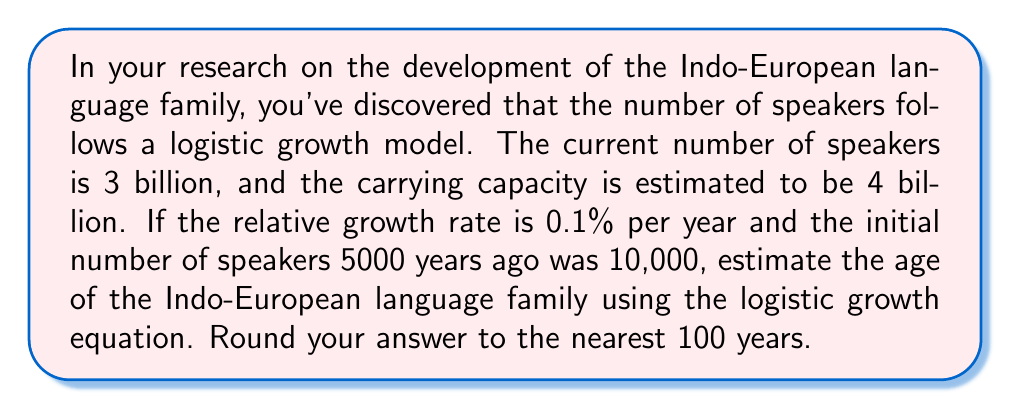Help me with this question. To solve this problem, we'll use the logistic growth equation and work backwards to find the age of the language family. The logistic growth equation is:

$$P(t) = \frac{K}{1 + (\frac{K}{P_0} - 1)e^{-rt}}$$

Where:
$P(t)$ is the population at time $t$
$K$ is the carrying capacity
$P_0$ is the initial population
$r$ is the relative growth rate
$t$ is the time

We know:
$P(t) = 3 \times 10^9$ (current number of speakers)
$K = 4 \times 10^9$ (carrying capacity)
$P_0 = 10,000 = 1 \times 10^4$ (initial number of speakers)
$r = 0.001$ (0.1% per year)

Let's substitute these values into the equation:

$$3 \times 10^9 = \frac{4 \times 10^9}{1 + (\frac{4 \times 10^9}{1 \times 10^4} - 1)e^{-0.001t}}$$

Now, let's solve for $t$:

1) Simplify the fraction:
   $$\frac{3}{4} = \frac{1}{1 + (4 \times 10^5 - 1)e^{-0.001t}}$$

2) Take the reciprocal of both sides:
   $$\frac{4}{3} = 1 + (4 \times 10^5 - 1)e^{-0.001t}$$

3) Subtract 1 from both sides:
   $$\frac{1}{3} = (4 \times 10^5 - 1)e^{-0.001t}$$

4) Divide both sides by $(4 \times 10^5 - 1)$:
   $$\frac{1}{3(4 \times 10^5 - 1)} = e^{-0.001t}$$

5) Take the natural log of both sides:
   $$\ln(\frac{1}{3(4 \times 10^5 - 1)}) = -0.001t$$

6) Solve for $t$:
   $$t = \frac{-\ln(\frac{1}{3(4 \times 10^5 - 1)})}{0.001}$$

7) Calculate the result:
   $$t \approx 12,971.85 \text{ years}$$

8) Round to the nearest 100 years:
   $$t \approx 13,000 \text{ years}$$

Therefore, the estimated age of the Indo-European language family is approximately 13,000 years.
Answer: 13,000 years 